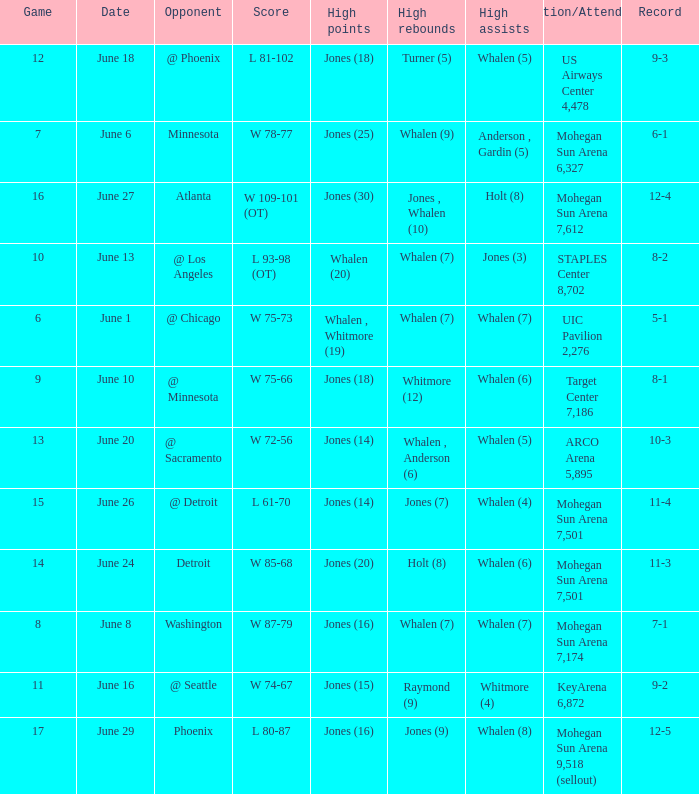What is the location/attendance when the record is 9-2? KeyArena 6,872. 